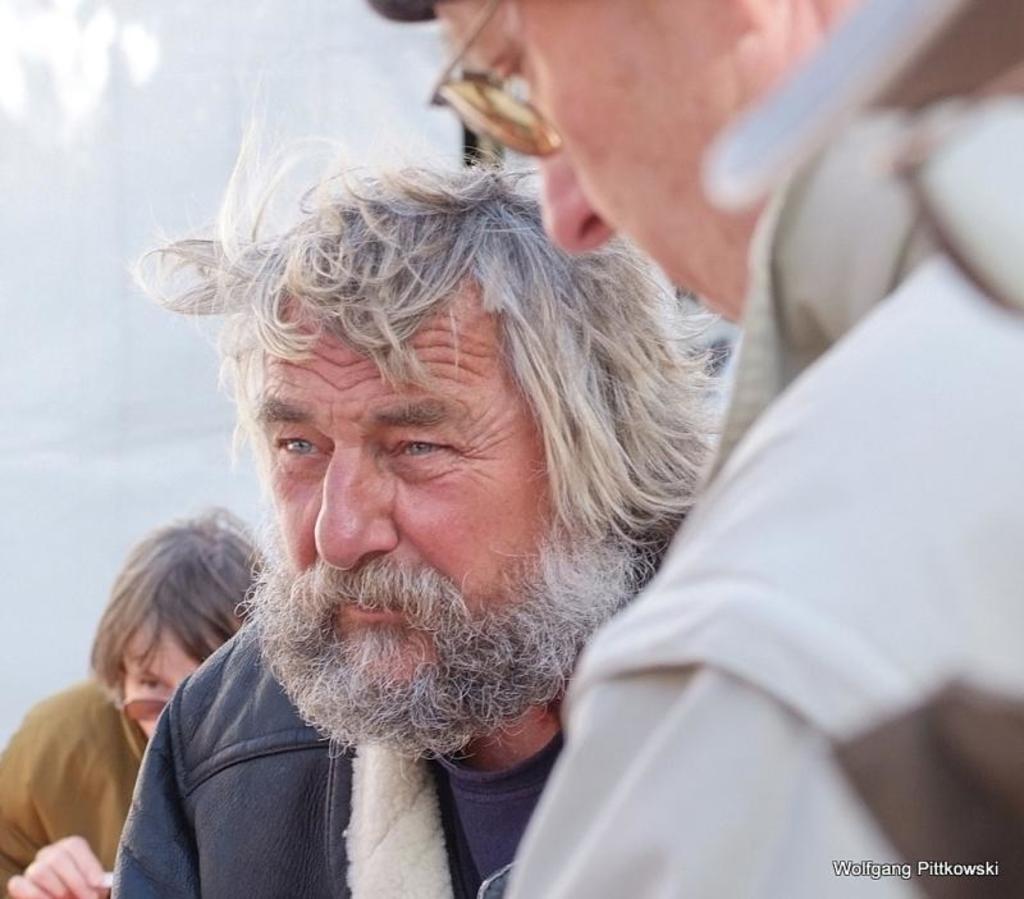How would you summarize this image in a sentence or two? In this image we can see people. At the bottom of the image there is text. In the background of the image there is wall. 